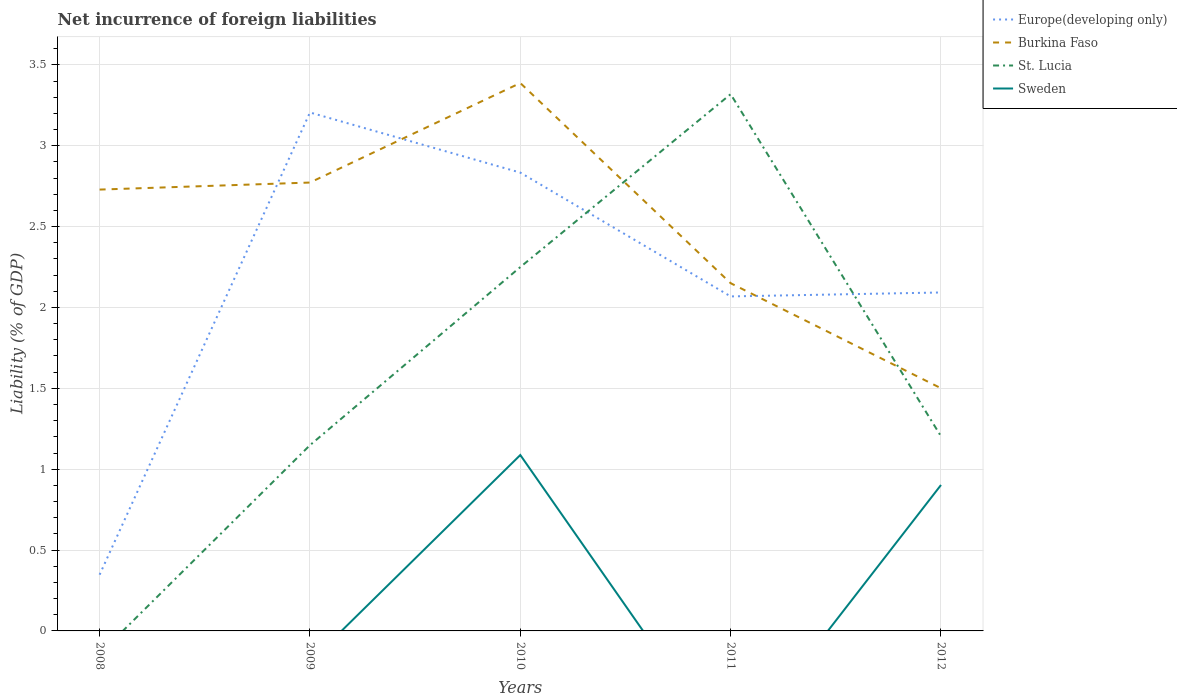Is the number of lines equal to the number of legend labels?
Your response must be concise. No. Across all years, what is the maximum net incurrence of foreign liabilities in Sweden?
Ensure brevity in your answer.  0. What is the total net incurrence of foreign liabilities in Europe(developing only) in the graph?
Your answer should be very brief. -0.02. What is the difference between the highest and the second highest net incurrence of foreign liabilities in Burkina Faso?
Your answer should be compact. 1.89. What is the difference between the highest and the lowest net incurrence of foreign liabilities in Sweden?
Offer a terse response. 2. How many lines are there?
Provide a succinct answer. 4. What is the difference between two consecutive major ticks on the Y-axis?
Ensure brevity in your answer.  0.5. How many legend labels are there?
Make the answer very short. 4. How are the legend labels stacked?
Your answer should be very brief. Vertical. What is the title of the graph?
Your answer should be compact. Net incurrence of foreign liabilities. What is the label or title of the X-axis?
Provide a succinct answer. Years. What is the label or title of the Y-axis?
Offer a very short reply. Liability (% of GDP). What is the Liability (% of GDP) in Europe(developing only) in 2008?
Give a very brief answer. 0.35. What is the Liability (% of GDP) in Burkina Faso in 2008?
Give a very brief answer. 2.73. What is the Liability (% of GDP) in Europe(developing only) in 2009?
Provide a short and direct response. 3.21. What is the Liability (% of GDP) in Burkina Faso in 2009?
Offer a very short reply. 2.77. What is the Liability (% of GDP) of St. Lucia in 2009?
Offer a very short reply. 1.15. What is the Liability (% of GDP) of Sweden in 2009?
Offer a very short reply. 0. What is the Liability (% of GDP) in Europe(developing only) in 2010?
Give a very brief answer. 2.83. What is the Liability (% of GDP) of Burkina Faso in 2010?
Your answer should be very brief. 3.39. What is the Liability (% of GDP) in St. Lucia in 2010?
Offer a terse response. 2.25. What is the Liability (% of GDP) of Sweden in 2010?
Keep it short and to the point. 1.09. What is the Liability (% of GDP) in Europe(developing only) in 2011?
Keep it short and to the point. 2.07. What is the Liability (% of GDP) of Burkina Faso in 2011?
Offer a very short reply. 2.15. What is the Liability (% of GDP) of St. Lucia in 2011?
Keep it short and to the point. 3.32. What is the Liability (% of GDP) of Europe(developing only) in 2012?
Offer a very short reply. 2.09. What is the Liability (% of GDP) in Burkina Faso in 2012?
Keep it short and to the point. 1.5. What is the Liability (% of GDP) of St. Lucia in 2012?
Give a very brief answer. 1.2. What is the Liability (% of GDP) of Sweden in 2012?
Ensure brevity in your answer.  0.9. Across all years, what is the maximum Liability (% of GDP) of Europe(developing only)?
Provide a succinct answer. 3.21. Across all years, what is the maximum Liability (% of GDP) of Burkina Faso?
Your response must be concise. 3.39. Across all years, what is the maximum Liability (% of GDP) in St. Lucia?
Ensure brevity in your answer.  3.32. Across all years, what is the maximum Liability (% of GDP) in Sweden?
Your answer should be very brief. 1.09. Across all years, what is the minimum Liability (% of GDP) of Europe(developing only)?
Provide a succinct answer. 0.35. Across all years, what is the minimum Liability (% of GDP) of Burkina Faso?
Ensure brevity in your answer.  1.5. Across all years, what is the minimum Liability (% of GDP) in St. Lucia?
Give a very brief answer. 0. What is the total Liability (% of GDP) in Europe(developing only) in the graph?
Make the answer very short. 10.55. What is the total Liability (% of GDP) of Burkina Faso in the graph?
Your answer should be very brief. 12.54. What is the total Liability (% of GDP) in St. Lucia in the graph?
Give a very brief answer. 7.92. What is the total Liability (% of GDP) of Sweden in the graph?
Your response must be concise. 1.99. What is the difference between the Liability (% of GDP) of Europe(developing only) in 2008 and that in 2009?
Your response must be concise. -2.86. What is the difference between the Liability (% of GDP) of Burkina Faso in 2008 and that in 2009?
Keep it short and to the point. -0.04. What is the difference between the Liability (% of GDP) of Europe(developing only) in 2008 and that in 2010?
Provide a short and direct response. -2.49. What is the difference between the Liability (% of GDP) of Burkina Faso in 2008 and that in 2010?
Keep it short and to the point. -0.66. What is the difference between the Liability (% of GDP) of Europe(developing only) in 2008 and that in 2011?
Your answer should be very brief. -1.72. What is the difference between the Liability (% of GDP) in Burkina Faso in 2008 and that in 2011?
Provide a short and direct response. 0.58. What is the difference between the Liability (% of GDP) in Europe(developing only) in 2008 and that in 2012?
Provide a short and direct response. -1.75. What is the difference between the Liability (% of GDP) of Burkina Faso in 2008 and that in 2012?
Your answer should be very brief. 1.23. What is the difference between the Liability (% of GDP) of Europe(developing only) in 2009 and that in 2010?
Make the answer very short. 0.37. What is the difference between the Liability (% of GDP) in Burkina Faso in 2009 and that in 2010?
Your answer should be very brief. -0.62. What is the difference between the Liability (% of GDP) of St. Lucia in 2009 and that in 2010?
Ensure brevity in your answer.  -1.1. What is the difference between the Liability (% of GDP) of Europe(developing only) in 2009 and that in 2011?
Give a very brief answer. 1.14. What is the difference between the Liability (% of GDP) in Burkina Faso in 2009 and that in 2011?
Offer a very short reply. 0.62. What is the difference between the Liability (% of GDP) in St. Lucia in 2009 and that in 2011?
Your response must be concise. -2.17. What is the difference between the Liability (% of GDP) in Europe(developing only) in 2009 and that in 2012?
Ensure brevity in your answer.  1.11. What is the difference between the Liability (% of GDP) in Burkina Faso in 2009 and that in 2012?
Provide a short and direct response. 1.27. What is the difference between the Liability (% of GDP) of St. Lucia in 2009 and that in 2012?
Keep it short and to the point. -0.05. What is the difference between the Liability (% of GDP) of Europe(developing only) in 2010 and that in 2011?
Ensure brevity in your answer.  0.77. What is the difference between the Liability (% of GDP) in Burkina Faso in 2010 and that in 2011?
Offer a very short reply. 1.24. What is the difference between the Liability (% of GDP) in St. Lucia in 2010 and that in 2011?
Offer a very short reply. -1.07. What is the difference between the Liability (% of GDP) in Europe(developing only) in 2010 and that in 2012?
Offer a very short reply. 0.74. What is the difference between the Liability (% of GDP) in Burkina Faso in 2010 and that in 2012?
Your response must be concise. 1.89. What is the difference between the Liability (% of GDP) of St. Lucia in 2010 and that in 2012?
Give a very brief answer. 1.05. What is the difference between the Liability (% of GDP) of Sweden in 2010 and that in 2012?
Give a very brief answer. 0.19. What is the difference between the Liability (% of GDP) of Europe(developing only) in 2011 and that in 2012?
Your answer should be very brief. -0.02. What is the difference between the Liability (% of GDP) in Burkina Faso in 2011 and that in 2012?
Offer a terse response. 0.65. What is the difference between the Liability (% of GDP) in St. Lucia in 2011 and that in 2012?
Provide a short and direct response. 2.12. What is the difference between the Liability (% of GDP) of Europe(developing only) in 2008 and the Liability (% of GDP) of Burkina Faso in 2009?
Provide a short and direct response. -2.42. What is the difference between the Liability (% of GDP) of Europe(developing only) in 2008 and the Liability (% of GDP) of St. Lucia in 2009?
Provide a succinct answer. -0.8. What is the difference between the Liability (% of GDP) in Burkina Faso in 2008 and the Liability (% of GDP) in St. Lucia in 2009?
Your answer should be very brief. 1.58. What is the difference between the Liability (% of GDP) in Europe(developing only) in 2008 and the Liability (% of GDP) in Burkina Faso in 2010?
Give a very brief answer. -3.04. What is the difference between the Liability (% of GDP) in Europe(developing only) in 2008 and the Liability (% of GDP) in St. Lucia in 2010?
Your answer should be very brief. -1.9. What is the difference between the Liability (% of GDP) of Europe(developing only) in 2008 and the Liability (% of GDP) of Sweden in 2010?
Offer a terse response. -0.74. What is the difference between the Liability (% of GDP) in Burkina Faso in 2008 and the Liability (% of GDP) in St. Lucia in 2010?
Offer a terse response. 0.48. What is the difference between the Liability (% of GDP) in Burkina Faso in 2008 and the Liability (% of GDP) in Sweden in 2010?
Keep it short and to the point. 1.64. What is the difference between the Liability (% of GDP) of Europe(developing only) in 2008 and the Liability (% of GDP) of Burkina Faso in 2011?
Make the answer very short. -1.8. What is the difference between the Liability (% of GDP) in Europe(developing only) in 2008 and the Liability (% of GDP) in St. Lucia in 2011?
Offer a very short reply. -2.97. What is the difference between the Liability (% of GDP) of Burkina Faso in 2008 and the Liability (% of GDP) of St. Lucia in 2011?
Ensure brevity in your answer.  -0.59. What is the difference between the Liability (% of GDP) of Europe(developing only) in 2008 and the Liability (% of GDP) of Burkina Faso in 2012?
Make the answer very short. -1.15. What is the difference between the Liability (% of GDP) in Europe(developing only) in 2008 and the Liability (% of GDP) in St. Lucia in 2012?
Your answer should be compact. -0.86. What is the difference between the Liability (% of GDP) of Europe(developing only) in 2008 and the Liability (% of GDP) of Sweden in 2012?
Give a very brief answer. -0.55. What is the difference between the Liability (% of GDP) of Burkina Faso in 2008 and the Liability (% of GDP) of St. Lucia in 2012?
Offer a very short reply. 1.53. What is the difference between the Liability (% of GDP) in Burkina Faso in 2008 and the Liability (% of GDP) in Sweden in 2012?
Make the answer very short. 1.83. What is the difference between the Liability (% of GDP) in Europe(developing only) in 2009 and the Liability (% of GDP) in Burkina Faso in 2010?
Offer a terse response. -0.18. What is the difference between the Liability (% of GDP) of Europe(developing only) in 2009 and the Liability (% of GDP) of St. Lucia in 2010?
Keep it short and to the point. 0.96. What is the difference between the Liability (% of GDP) in Europe(developing only) in 2009 and the Liability (% of GDP) in Sweden in 2010?
Keep it short and to the point. 2.12. What is the difference between the Liability (% of GDP) of Burkina Faso in 2009 and the Liability (% of GDP) of St. Lucia in 2010?
Make the answer very short. 0.52. What is the difference between the Liability (% of GDP) of Burkina Faso in 2009 and the Liability (% of GDP) of Sweden in 2010?
Keep it short and to the point. 1.68. What is the difference between the Liability (% of GDP) of St. Lucia in 2009 and the Liability (% of GDP) of Sweden in 2010?
Provide a succinct answer. 0.06. What is the difference between the Liability (% of GDP) of Europe(developing only) in 2009 and the Liability (% of GDP) of Burkina Faso in 2011?
Your response must be concise. 1.06. What is the difference between the Liability (% of GDP) in Europe(developing only) in 2009 and the Liability (% of GDP) in St. Lucia in 2011?
Offer a terse response. -0.11. What is the difference between the Liability (% of GDP) of Burkina Faso in 2009 and the Liability (% of GDP) of St. Lucia in 2011?
Your answer should be very brief. -0.55. What is the difference between the Liability (% of GDP) in Europe(developing only) in 2009 and the Liability (% of GDP) in Burkina Faso in 2012?
Make the answer very short. 1.71. What is the difference between the Liability (% of GDP) of Europe(developing only) in 2009 and the Liability (% of GDP) of St. Lucia in 2012?
Ensure brevity in your answer.  2. What is the difference between the Liability (% of GDP) in Europe(developing only) in 2009 and the Liability (% of GDP) in Sweden in 2012?
Provide a succinct answer. 2.3. What is the difference between the Liability (% of GDP) of Burkina Faso in 2009 and the Liability (% of GDP) of St. Lucia in 2012?
Keep it short and to the point. 1.57. What is the difference between the Liability (% of GDP) of Burkina Faso in 2009 and the Liability (% of GDP) of Sweden in 2012?
Ensure brevity in your answer.  1.87. What is the difference between the Liability (% of GDP) in St. Lucia in 2009 and the Liability (% of GDP) in Sweden in 2012?
Your answer should be compact. 0.25. What is the difference between the Liability (% of GDP) in Europe(developing only) in 2010 and the Liability (% of GDP) in Burkina Faso in 2011?
Ensure brevity in your answer.  0.68. What is the difference between the Liability (% of GDP) in Europe(developing only) in 2010 and the Liability (% of GDP) in St. Lucia in 2011?
Ensure brevity in your answer.  -0.48. What is the difference between the Liability (% of GDP) in Burkina Faso in 2010 and the Liability (% of GDP) in St. Lucia in 2011?
Ensure brevity in your answer.  0.07. What is the difference between the Liability (% of GDP) of Europe(developing only) in 2010 and the Liability (% of GDP) of Burkina Faso in 2012?
Ensure brevity in your answer.  1.33. What is the difference between the Liability (% of GDP) in Europe(developing only) in 2010 and the Liability (% of GDP) in St. Lucia in 2012?
Ensure brevity in your answer.  1.63. What is the difference between the Liability (% of GDP) in Europe(developing only) in 2010 and the Liability (% of GDP) in Sweden in 2012?
Make the answer very short. 1.93. What is the difference between the Liability (% of GDP) in Burkina Faso in 2010 and the Liability (% of GDP) in St. Lucia in 2012?
Ensure brevity in your answer.  2.18. What is the difference between the Liability (% of GDP) of Burkina Faso in 2010 and the Liability (% of GDP) of Sweden in 2012?
Ensure brevity in your answer.  2.49. What is the difference between the Liability (% of GDP) of St. Lucia in 2010 and the Liability (% of GDP) of Sweden in 2012?
Make the answer very short. 1.35. What is the difference between the Liability (% of GDP) of Europe(developing only) in 2011 and the Liability (% of GDP) of Burkina Faso in 2012?
Provide a short and direct response. 0.57. What is the difference between the Liability (% of GDP) of Europe(developing only) in 2011 and the Liability (% of GDP) of St. Lucia in 2012?
Make the answer very short. 0.86. What is the difference between the Liability (% of GDP) of Europe(developing only) in 2011 and the Liability (% of GDP) of Sweden in 2012?
Your answer should be compact. 1.17. What is the difference between the Liability (% of GDP) in Burkina Faso in 2011 and the Liability (% of GDP) in St. Lucia in 2012?
Make the answer very short. 0.95. What is the difference between the Liability (% of GDP) of Burkina Faso in 2011 and the Liability (% of GDP) of Sweden in 2012?
Make the answer very short. 1.25. What is the difference between the Liability (% of GDP) in St. Lucia in 2011 and the Liability (% of GDP) in Sweden in 2012?
Provide a short and direct response. 2.42. What is the average Liability (% of GDP) in Europe(developing only) per year?
Offer a terse response. 2.11. What is the average Liability (% of GDP) in Burkina Faso per year?
Provide a succinct answer. 2.51. What is the average Liability (% of GDP) in St. Lucia per year?
Your response must be concise. 1.58. What is the average Liability (% of GDP) of Sweden per year?
Give a very brief answer. 0.4. In the year 2008, what is the difference between the Liability (% of GDP) of Europe(developing only) and Liability (% of GDP) of Burkina Faso?
Keep it short and to the point. -2.38. In the year 2009, what is the difference between the Liability (% of GDP) in Europe(developing only) and Liability (% of GDP) in Burkina Faso?
Provide a short and direct response. 0.43. In the year 2009, what is the difference between the Liability (% of GDP) in Europe(developing only) and Liability (% of GDP) in St. Lucia?
Your answer should be very brief. 2.06. In the year 2009, what is the difference between the Liability (% of GDP) in Burkina Faso and Liability (% of GDP) in St. Lucia?
Your answer should be compact. 1.62. In the year 2010, what is the difference between the Liability (% of GDP) of Europe(developing only) and Liability (% of GDP) of Burkina Faso?
Keep it short and to the point. -0.55. In the year 2010, what is the difference between the Liability (% of GDP) in Europe(developing only) and Liability (% of GDP) in St. Lucia?
Offer a terse response. 0.58. In the year 2010, what is the difference between the Liability (% of GDP) of Europe(developing only) and Liability (% of GDP) of Sweden?
Your answer should be compact. 1.75. In the year 2010, what is the difference between the Liability (% of GDP) in Burkina Faso and Liability (% of GDP) in St. Lucia?
Ensure brevity in your answer.  1.14. In the year 2010, what is the difference between the Liability (% of GDP) in Burkina Faso and Liability (% of GDP) in Sweden?
Offer a terse response. 2.3. In the year 2010, what is the difference between the Liability (% of GDP) of St. Lucia and Liability (% of GDP) of Sweden?
Provide a succinct answer. 1.16. In the year 2011, what is the difference between the Liability (% of GDP) in Europe(developing only) and Liability (% of GDP) in Burkina Faso?
Offer a very short reply. -0.08. In the year 2011, what is the difference between the Liability (% of GDP) in Europe(developing only) and Liability (% of GDP) in St. Lucia?
Provide a short and direct response. -1.25. In the year 2011, what is the difference between the Liability (% of GDP) in Burkina Faso and Liability (% of GDP) in St. Lucia?
Your response must be concise. -1.17. In the year 2012, what is the difference between the Liability (% of GDP) of Europe(developing only) and Liability (% of GDP) of Burkina Faso?
Your answer should be compact. 0.59. In the year 2012, what is the difference between the Liability (% of GDP) in Europe(developing only) and Liability (% of GDP) in St. Lucia?
Ensure brevity in your answer.  0.89. In the year 2012, what is the difference between the Liability (% of GDP) in Europe(developing only) and Liability (% of GDP) in Sweden?
Make the answer very short. 1.19. In the year 2012, what is the difference between the Liability (% of GDP) in Burkina Faso and Liability (% of GDP) in St. Lucia?
Provide a succinct answer. 0.3. In the year 2012, what is the difference between the Liability (% of GDP) of Burkina Faso and Liability (% of GDP) of Sweden?
Ensure brevity in your answer.  0.6. In the year 2012, what is the difference between the Liability (% of GDP) of St. Lucia and Liability (% of GDP) of Sweden?
Your response must be concise. 0.3. What is the ratio of the Liability (% of GDP) of Europe(developing only) in 2008 to that in 2009?
Provide a succinct answer. 0.11. What is the ratio of the Liability (% of GDP) in Burkina Faso in 2008 to that in 2009?
Make the answer very short. 0.98. What is the ratio of the Liability (% of GDP) of Europe(developing only) in 2008 to that in 2010?
Offer a very short reply. 0.12. What is the ratio of the Liability (% of GDP) of Burkina Faso in 2008 to that in 2010?
Ensure brevity in your answer.  0.81. What is the ratio of the Liability (% of GDP) of Europe(developing only) in 2008 to that in 2011?
Provide a short and direct response. 0.17. What is the ratio of the Liability (% of GDP) in Burkina Faso in 2008 to that in 2011?
Provide a succinct answer. 1.27. What is the ratio of the Liability (% of GDP) of Europe(developing only) in 2008 to that in 2012?
Give a very brief answer. 0.17. What is the ratio of the Liability (% of GDP) of Burkina Faso in 2008 to that in 2012?
Provide a short and direct response. 1.82. What is the ratio of the Liability (% of GDP) in Europe(developing only) in 2009 to that in 2010?
Make the answer very short. 1.13. What is the ratio of the Liability (% of GDP) of Burkina Faso in 2009 to that in 2010?
Provide a short and direct response. 0.82. What is the ratio of the Liability (% of GDP) in St. Lucia in 2009 to that in 2010?
Provide a succinct answer. 0.51. What is the ratio of the Liability (% of GDP) in Europe(developing only) in 2009 to that in 2011?
Your answer should be compact. 1.55. What is the ratio of the Liability (% of GDP) in Burkina Faso in 2009 to that in 2011?
Your answer should be compact. 1.29. What is the ratio of the Liability (% of GDP) in St. Lucia in 2009 to that in 2011?
Your answer should be compact. 0.35. What is the ratio of the Liability (% of GDP) of Europe(developing only) in 2009 to that in 2012?
Ensure brevity in your answer.  1.53. What is the ratio of the Liability (% of GDP) of Burkina Faso in 2009 to that in 2012?
Make the answer very short. 1.85. What is the ratio of the Liability (% of GDP) in St. Lucia in 2009 to that in 2012?
Your answer should be compact. 0.95. What is the ratio of the Liability (% of GDP) in Europe(developing only) in 2010 to that in 2011?
Provide a succinct answer. 1.37. What is the ratio of the Liability (% of GDP) of Burkina Faso in 2010 to that in 2011?
Your response must be concise. 1.58. What is the ratio of the Liability (% of GDP) in St. Lucia in 2010 to that in 2011?
Your response must be concise. 0.68. What is the ratio of the Liability (% of GDP) in Europe(developing only) in 2010 to that in 2012?
Your response must be concise. 1.35. What is the ratio of the Liability (% of GDP) of Burkina Faso in 2010 to that in 2012?
Make the answer very short. 2.26. What is the ratio of the Liability (% of GDP) in St. Lucia in 2010 to that in 2012?
Ensure brevity in your answer.  1.87. What is the ratio of the Liability (% of GDP) of Sweden in 2010 to that in 2012?
Your answer should be very brief. 1.21. What is the ratio of the Liability (% of GDP) in Europe(developing only) in 2011 to that in 2012?
Keep it short and to the point. 0.99. What is the ratio of the Liability (% of GDP) in Burkina Faso in 2011 to that in 2012?
Your response must be concise. 1.43. What is the ratio of the Liability (% of GDP) of St. Lucia in 2011 to that in 2012?
Offer a terse response. 2.76. What is the difference between the highest and the second highest Liability (% of GDP) of Europe(developing only)?
Ensure brevity in your answer.  0.37. What is the difference between the highest and the second highest Liability (% of GDP) of Burkina Faso?
Make the answer very short. 0.62. What is the difference between the highest and the second highest Liability (% of GDP) in St. Lucia?
Give a very brief answer. 1.07. What is the difference between the highest and the lowest Liability (% of GDP) of Europe(developing only)?
Ensure brevity in your answer.  2.86. What is the difference between the highest and the lowest Liability (% of GDP) of Burkina Faso?
Your answer should be very brief. 1.89. What is the difference between the highest and the lowest Liability (% of GDP) in St. Lucia?
Make the answer very short. 3.32. What is the difference between the highest and the lowest Liability (% of GDP) in Sweden?
Make the answer very short. 1.09. 